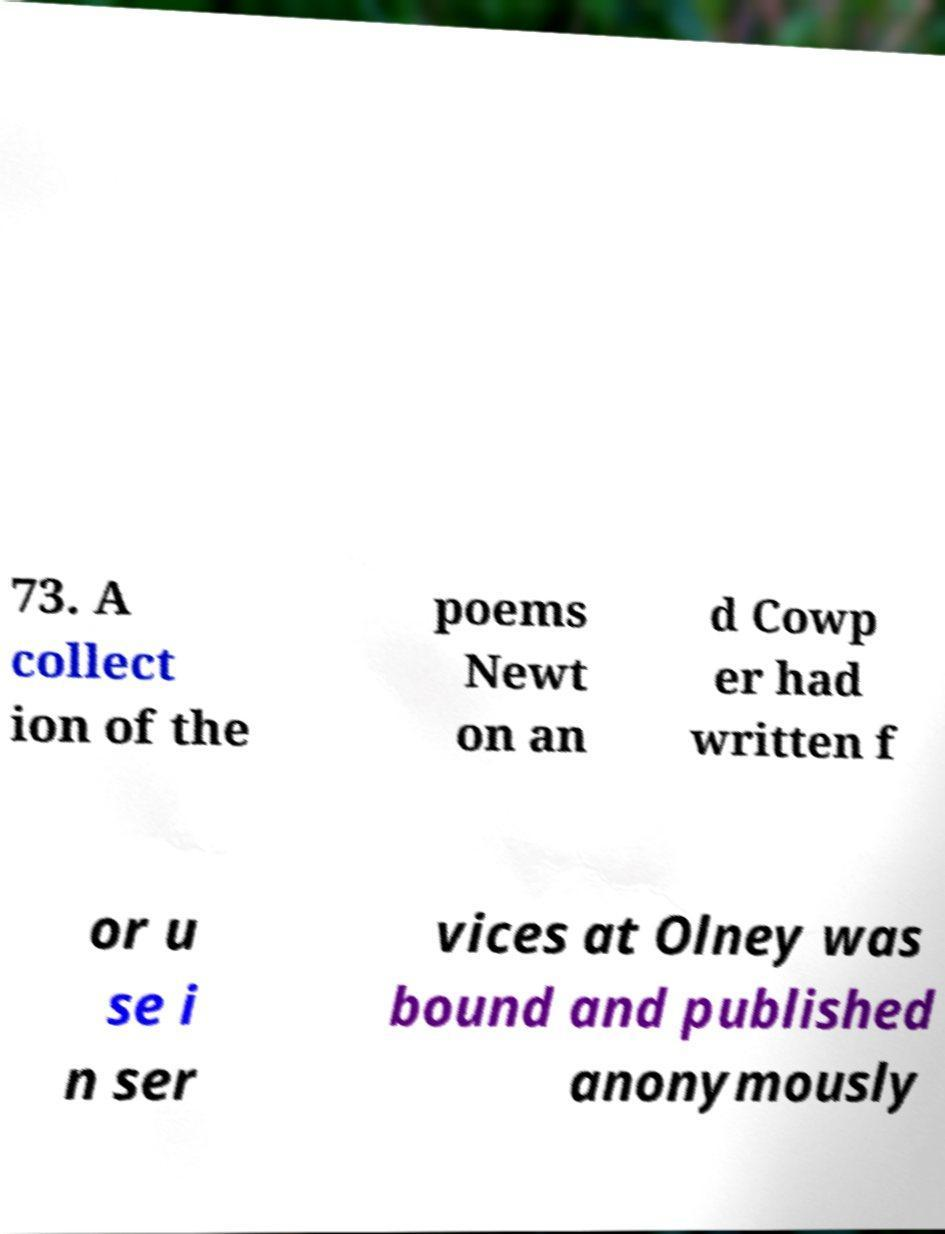There's text embedded in this image that I need extracted. Can you transcribe it verbatim? 73. A collect ion of the poems Newt on an d Cowp er had written f or u se i n ser vices at Olney was bound and published anonymously 